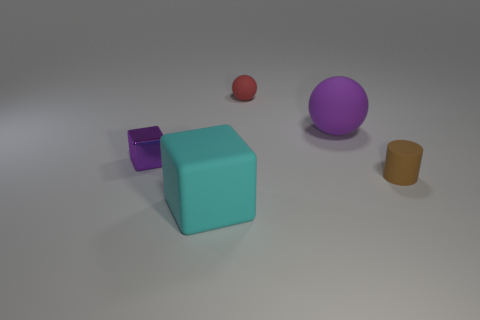The big object that is to the left of the red rubber thing has what shape?
Keep it short and to the point. Cube. Does the tiny brown rubber object have the same shape as the cyan thing?
Give a very brief answer. No. Is the number of small brown cylinders that are in front of the large block the same as the number of brown shiny cubes?
Provide a short and direct response. Yes. The red rubber object is what shape?
Provide a short and direct response. Sphere. Are there any other things that have the same color as the large rubber block?
Offer a very short reply. No. There is a matte object that is in front of the small brown cylinder; does it have the same size as the block behind the rubber cylinder?
Ensure brevity in your answer.  No. What is the shape of the tiny thing that is behind the big sphere that is to the right of the red matte thing?
Your answer should be compact. Sphere. There is a shiny thing; does it have the same size as the cylinder that is in front of the small block?
Offer a terse response. Yes. There is a brown rubber cylinder to the right of the block that is behind the tiny rubber thing that is in front of the big purple matte thing; what size is it?
Provide a succinct answer. Small. What number of things are rubber objects on the right side of the large block or big matte cylinders?
Give a very brief answer. 3. 